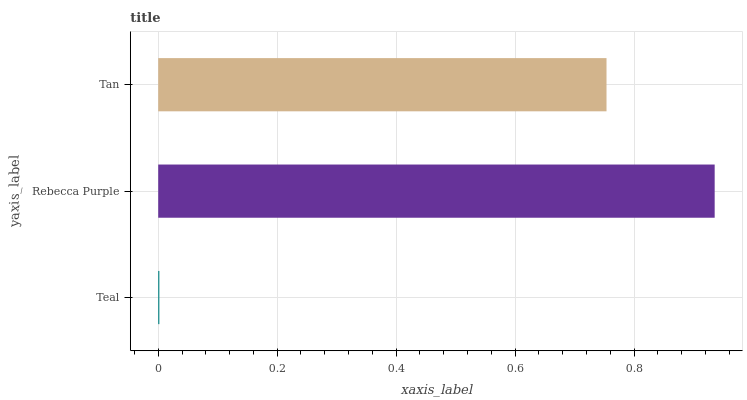Is Teal the minimum?
Answer yes or no. Yes. Is Rebecca Purple the maximum?
Answer yes or no. Yes. Is Tan the minimum?
Answer yes or no. No. Is Tan the maximum?
Answer yes or no. No. Is Rebecca Purple greater than Tan?
Answer yes or no. Yes. Is Tan less than Rebecca Purple?
Answer yes or no. Yes. Is Tan greater than Rebecca Purple?
Answer yes or no. No. Is Rebecca Purple less than Tan?
Answer yes or no. No. Is Tan the high median?
Answer yes or no. Yes. Is Tan the low median?
Answer yes or no. Yes. Is Teal the high median?
Answer yes or no. No. Is Teal the low median?
Answer yes or no. No. 